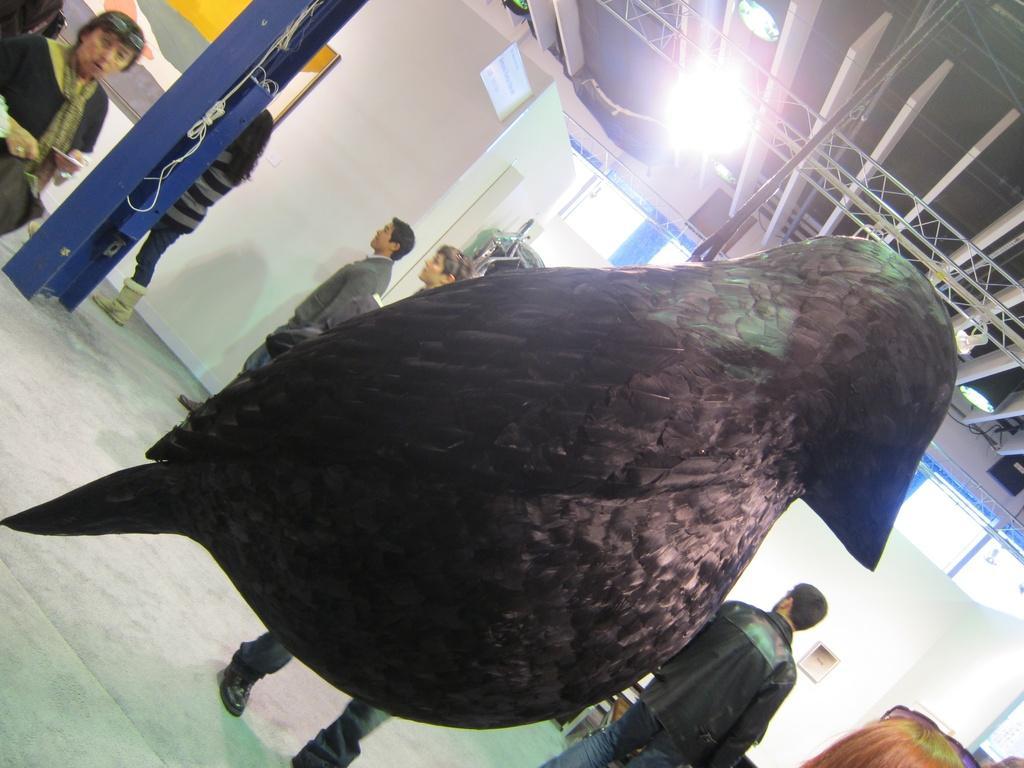Describe this image in one or two sentences. In this picture we can see a statue of a bird and in the background we can see people on the floor and we can see boards and some objects. 